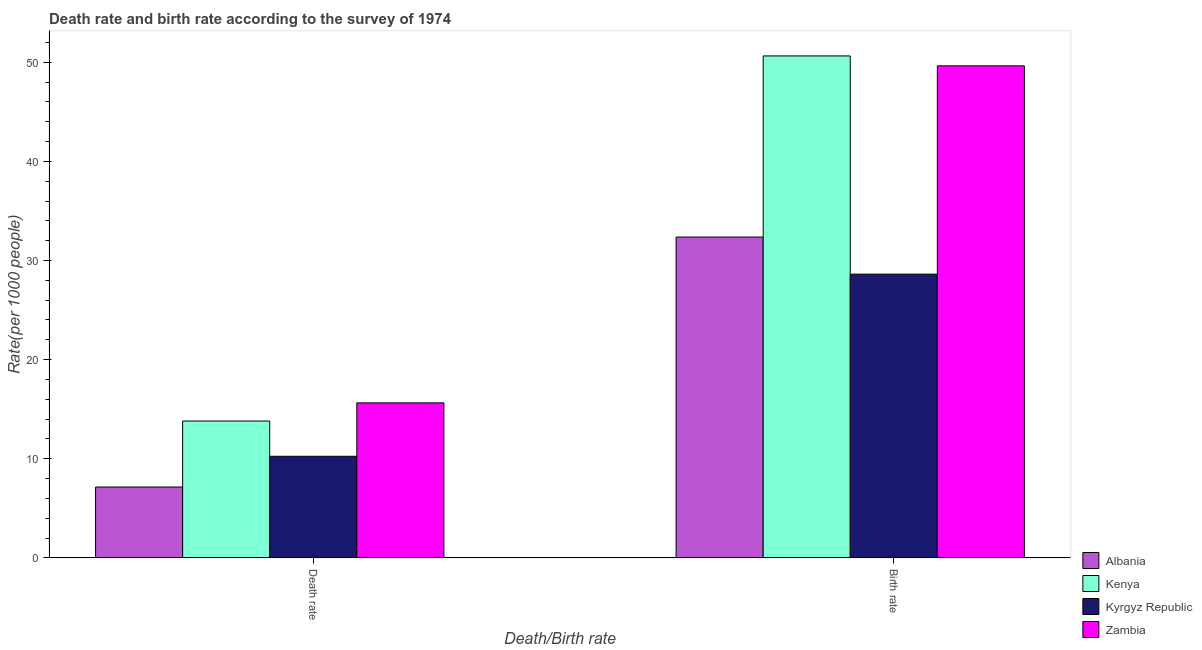How many groups of bars are there?
Your answer should be compact. 2. Are the number of bars on each tick of the X-axis equal?
Your response must be concise. Yes. How many bars are there on the 1st tick from the right?
Keep it short and to the point. 4. What is the label of the 1st group of bars from the left?
Offer a very short reply. Death rate. What is the birth rate in Zambia?
Offer a very short reply. 49.64. Across all countries, what is the maximum birth rate?
Offer a very short reply. 50.64. Across all countries, what is the minimum birth rate?
Keep it short and to the point. 28.62. In which country was the death rate maximum?
Ensure brevity in your answer.  Zambia. In which country was the death rate minimum?
Ensure brevity in your answer.  Albania. What is the total birth rate in the graph?
Offer a terse response. 161.27. What is the difference between the birth rate in Zambia and that in Kenya?
Provide a short and direct response. -1. What is the difference between the death rate in Kenya and the birth rate in Kyrgyz Republic?
Offer a very short reply. -14.82. What is the average death rate per country?
Your answer should be very brief. 11.71. What is the difference between the birth rate and death rate in Kyrgyz Republic?
Your answer should be compact. 18.37. What is the ratio of the birth rate in Albania to that in Kyrgyz Republic?
Keep it short and to the point. 1.13. What does the 1st bar from the left in Death rate represents?
Your answer should be very brief. Albania. What does the 3rd bar from the right in Death rate represents?
Provide a short and direct response. Kenya. How many bars are there?
Make the answer very short. 8. Are all the bars in the graph horizontal?
Provide a short and direct response. No. How many countries are there in the graph?
Give a very brief answer. 4. What is the difference between two consecutive major ticks on the Y-axis?
Your answer should be compact. 10. Does the graph contain any zero values?
Offer a very short reply. No. How are the legend labels stacked?
Ensure brevity in your answer.  Vertical. What is the title of the graph?
Offer a very short reply. Death rate and birth rate according to the survey of 1974. What is the label or title of the X-axis?
Keep it short and to the point. Death/Birth rate. What is the label or title of the Y-axis?
Offer a terse response. Rate(per 1000 people). What is the Rate(per 1000 people) in Albania in Death rate?
Your response must be concise. 7.15. What is the Rate(per 1000 people) of Kenya in Death rate?
Your answer should be very brief. 13.81. What is the Rate(per 1000 people) in Kyrgyz Republic in Death rate?
Offer a terse response. 10.25. What is the Rate(per 1000 people) of Zambia in Death rate?
Your answer should be very brief. 15.64. What is the Rate(per 1000 people) of Albania in Birth rate?
Keep it short and to the point. 32.37. What is the Rate(per 1000 people) in Kenya in Birth rate?
Your response must be concise. 50.64. What is the Rate(per 1000 people) in Kyrgyz Republic in Birth rate?
Your answer should be compact. 28.62. What is the Rate(per 1000 people) in Zambia in Birth rate?
Your response must be concise. 49.64. Across all Death/Birth rate, what is the maximum Rate(per 1000 people) in Albania?
Offer a terse response. 32.37. Across all Death/Birth rate, what is the maximum Rate(per 1000 people) in Kenya?
Your answer should be very brief. 50.64. Across all Death/Birth rate, what is the maximum Rate(per 1000 people) of Kyrgyz Republic?
Offer a terse response. 28.62. Across all Death/Birth rate, what is the maximum Rate(per 1000 people) in Zambia?
Offer a very short reply. 49.64. Across all Death/Birth rate, what is the minimum Rate(per 1000 people) in Albania?
Provide a short and direct response. 7.15. Across all Death/Birth rate, what is the minimum Rate(per 1000 people) of Kenya?
Offer a terse response. 13.81. Across all Death/Birth rate, what is the minimum Rate(per 1000 people) in Kyrgyz Republic?
Ensure brevity in your answer.  10.25. Across all Death/Birth rate, what is the minimum Rate(per 1000 people) in Zambia?
Ensure brevity in your answer.  15.64. What is the total Rate(per 1000 people) of Albania in the graph?
Ensure brevity in your answer.  39.52. What is the total Rate(per 1000 people) of Kenya in the graph?
Provide a succinct answer. 64.44. What is the total Rate(per 1000 people) of Kyrgyz Republic in the graph?
Offer a very short reply. 38.88. What is the total Rate(per 1000 people) of Zambia in the graph?
Your response must be concise. 65.28. What is the difference between the Rate(per 1000 people) of Albania in Death rate and that in Birth rate?
Your answer should be very brief. -25.22. What is the difference between the Rate(per 1000 people) of Kenya in Death rate and that in Birth rate?
Offer a very short reply. -36.83. What is the difference between the Rate(per 1000 people) in Kyrgyz Republic in Death rate and that in Birth rate?
Provide a succinct answer. -18.37. What is the difference between the Rate(per 1000 people) in Zambia in Death rate and that in Birth rate?
Offer a very short reply. -34. What is the difference between the Rate(per 1000 people) of Albania in Death rate and the Rate(per 1000 people) of Kenya in Birth rate?
Keep it short and to the point. -43.49. What is the difference between the Rate(per 1000 people) in Albania in Death rate and the Rate(per 1000 people) in Kyrgyz Republic in Birth rate?
Offer a very short reply. -21.48. What is the difference between the Rate(per 1000 people) of Albania in Death rate and the Rate(per 1000 people) of Zambia in Birth rate?
Your response must be concise. -42.49. What is the difference between the Rate(per 1000 people) of Kenya in Death rate and the Rate(per 1000 people) of Kyrgyz Republic in Birth rate?
Give a very brief answer. -14.82. What is the difference between the Rate(per 1000 people) of Kenya in Death rate and the Rate(per 1000 people) of Zambia in Birth rate?
Provide a short and direct response. -35.83. What is the difference between the Rate(per 1000 people) of Kyrgyz Republic in Death rate and the Rate(per 1000 people) of Zambia in Birth rate?
Your answer should be compact. -39.39. What is the average Rate(per 1000 people) of Albania per Death/Birth rate?
Ensure brevity in your answer.  19.76. What is the average Rate(per 1000 people) in Kenya per Death/Birth rate?
Give a very brief answer. 32.22. What is the average Rate(per 1000 people) in Kyrgyz Republic per Death/Birth rate?
Offer a very short reply. 19.44. What is the average Rate(per 1000 people) of Zambia per Death/Birth rate?
Your answer should be very brief. 32.64. What is the difference between the Rate(per 1000 people) of Albania and Rate(per 1000 people) of Kenya in Death rate?
Provide a short and direct response. -6.66. What is the difference between the Rate(per 1000 people) of Albania and Rate(per 1000 people) of Kyrgyz Republic in Death rate?
Keep it short and to the point. -3.1. What is the difference between the Rate(per 1000 people) of Albania and Rate(per 1000 people) of Zambia in Death rate?
Provide a short and direct response. -8.49. What is the difference between the Rate(per 1000 people) in Kenya and Rate(per 1000 people) in Kyrgyz Republic in Death rate?
Ensure brevity in your answer.  3.56. What is the difference between the Rate(per 1000 people) in Kenya and Rate(per 1000 people) in Zambia in Death rate?
Make the answer very short. -1.83. What is the difference between the Rate(per 1000 people) of Kyrgyz Republic and Rate(per 1000 people) of Zambia in Death rate?
Make the answer very short. -5.39. What is the difference between the Rate(per 1000 people) in Albania and Rate(per 1000 people) in Kenya in Birth rate?
Keep it short and to the point. -18.27. What is the difference between the Rate(per 1000 people) of Albania and Rate(per 1000 people) of Kyrgyz Republic in Birth rate?
Your response must be concise. 3.74. What is the difference between the Rate(per 1000 people) of Albania and Rate(per 1000 people) of Zambia in Birth rate?
Your answer should be compact. -17.27. What is the difference between the Rate(per 1000 people) in Kenya and Rate(per 1000 people) in Kyrgyz Republic in Birth rate?
Give a very brief answer. 22.01. What is the difference between the Rate(per 1000 people) in Kyrgyz Republic and Rate(per 1000 people) in Zambia in Birth rate?
Provide a short and direct response. -21.01. What is the ratio of the Rate(per 1000 people) of Albania in Death rate to that in Birth rate?
Offer a terse response. 0.22. What is the ratio of the Rate(per 1000 people) of Kenya in Death rate to that in Birth rate?
Make the answer very short. 0.27. What is the ratio of the Rate(per 1000 people) of Kyrgyz Republic in Death rate to that in Birth rate?
Your answer should be very brief. 0.36. What is the ratio of the Rate(per 1000 people) in Zambia in Death rate to that in Birth rate?
Make the answer very short. 0.32. What is the difference between the highest and the second highest Rate(per 1000 people) in Albania?
Keep it short and to the point. 25.22. What is the difference between the highest and the second highest Rate(per 1000 people) in Kenya?
Your answer should be very brief. 36.83. What is the difference between the highest and the second highest Rate(per 1000 people) of Kyrgyz Republic?
Ensure brevity in your answer.  18.37. What is the difference between the highest and the second highest Rate(per 1000 people) of Zambia?
Keep it short and to the point. 34. What is the difference between the highest and the lowest Rate(per 1000 people) of Albania?
Give a very brief answer. 25.22. What is the difference between the highest and the lowest Rate(per 1000 people) in Kenya?
Offer a very short reply. 36.83. What is the difference between the highest and the lowest Rate(per 1000 people) in Kyrgyz Republic?
Provide a short and direct response. 18.37. 